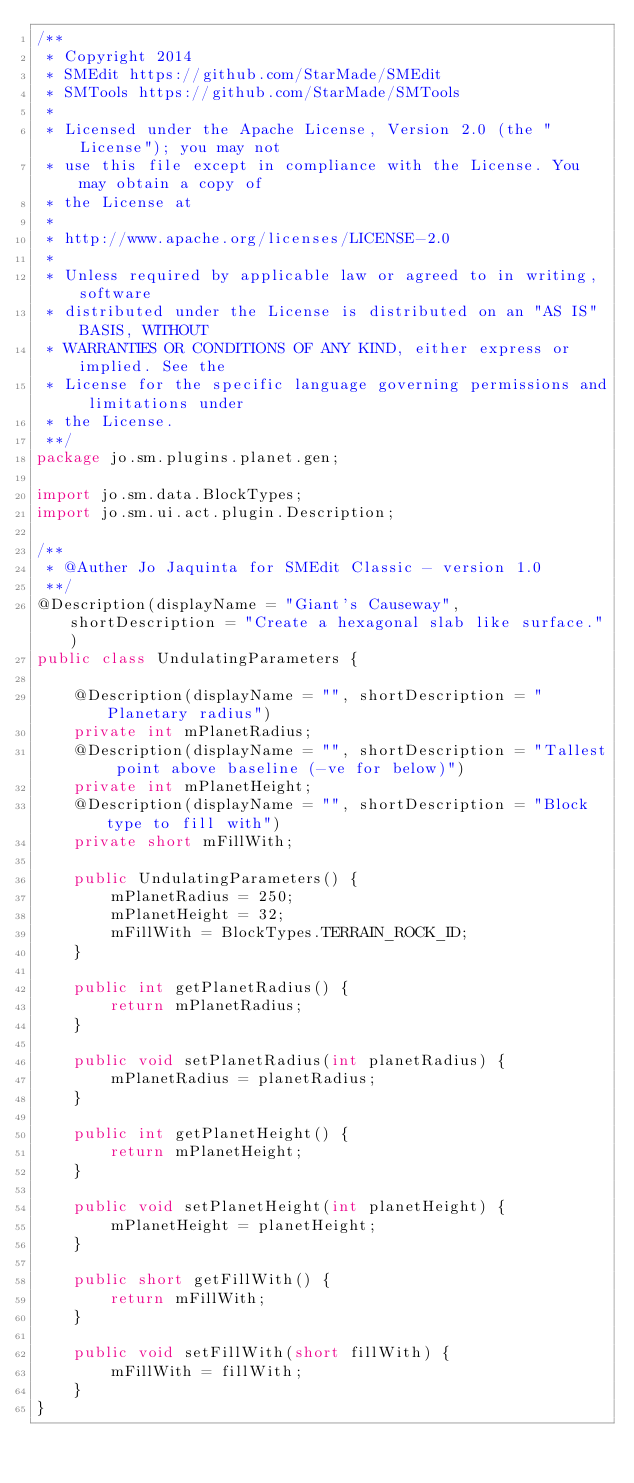<code> <loc_0><loc_0><loc_500><loc_500><_Java_>/**
 * Copyright 2014 
 * SMEdit https://github.com/StarMade/SMEdit
 * SMTools https://github.com/StarMade/SMTools
 *
 * Licensed under the Apache License, Version 2.0 (the "License"); you may not
 * use this file except in compliance with the License. You may obtain a copy of
 * the License at
 *
 * http://www.apache.org/licenses/LICENSE-2.0
 *
 * Unless required by applicable law or agreed to in writing, software
 * distributed under the License is distributed on an "AS IS" BASIS, WITHOUT
 * WARRANTIES OR CONDITIONS OF ANY KIND, either express or implied. See the
 * License for the specific language governing permissions and limitations under
 * the License.
 **/
package jo.sm.plugins.planet.gen;

import jo.sm.data.BlockTypes;
import jo.sm.ui.act.plugin.Description;

/**
 * @Auther Jo Jaquinta for SMEdit Classic - version 1.0
 **/
@Description(displayName = "Giant's Causeway", shortDescription = "Create a hexagonal slab like surface.")
public class UndulatingParameters {

    @Description(displayName = "", shortDescription = "Planetary radius")
    private int mPlanetRadius;
    @Description(displayName = "", shortDescription = "Tallest point above baseline (-ve for below)")
    private int mPlanetHeight;
    @Description(displayName = "", shortDescription = "Block type to fill with")
    private short mFillWith;

    public UndulatingParameters() {
        mPlanetRadius = 250;
        mPlanetHeight = 32;
        mFillWith = BlockTypes.TERRAIN_ROCK_ID;
    }

    public int getPlanetRadius() {
        return mPlanetRadius;
    }

    public void setPlanetRadius(int planetRadius) {
        mPlanetRadius = planetRadius;
    }

    public int getPlanetHeight() {
        return mPlanetHeight;
    }

    public void setPlanetHeight(int planetHeight) {
        mPlanetHeight = planetHeight;
    }

    public short getFillWith() {
        return mFillWith;
    }

    public void setFillWith(short fillWith) {
        mFillWith = fillWith;
    }
}
</code> 